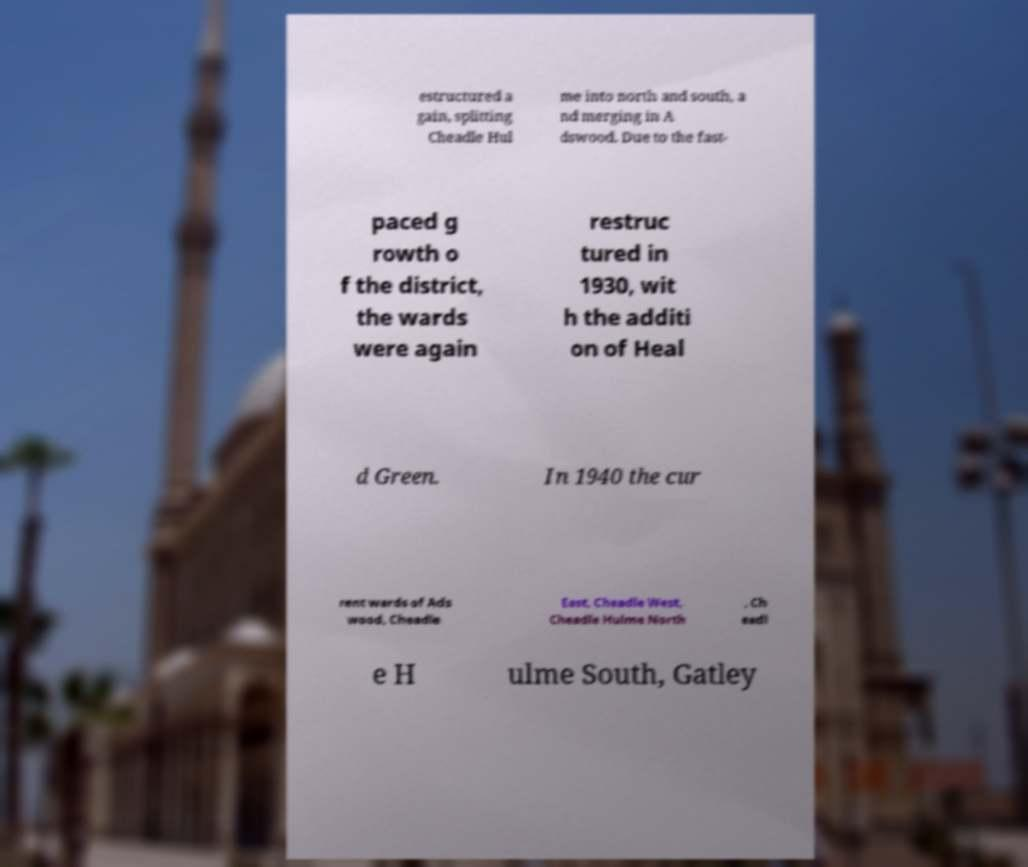Can you accurately transcribe the text from the provided image for me? estructured a gain, splitting Cheadle Hul me into north and south, a nd merging in A dswood. Due to the fast- paced g rowth o f the district, the wards were again restruc tured in 1930, wit h the additi on of Heal d Green. In 1940 the cur rent wards of Ads wood, Cheadle East, Cheadle West, Cheadle Hulme North , Ch eadl e H ulme South, Gatley 